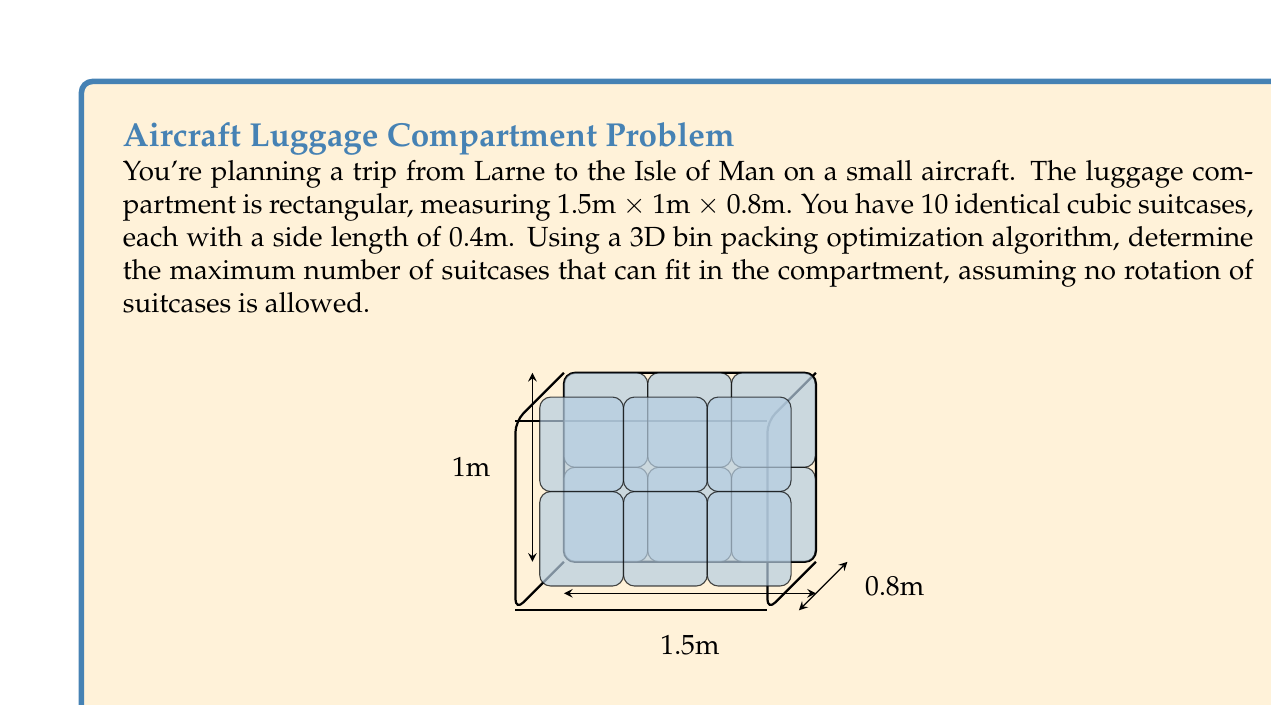Provide a solution to this math problem. Let's approach this step-by-step:

1) First, we need to determine how many suitcases can fit along each dimension of the compartment:

   Length: $\frac{1.5\text{m}}{0.4\text{m}} = 3.75$ (rounds down to 3)
   Width: $\frac{1\text{m}}{0.4\text{m}} = 2.5$ (rounds down to 2)
   Height: $\frac{0.8\text{m}}{0.4\text{m}} = 2$

2) The maximum number of suitcases that can fit is the product of these numbers:

   $$3 \times 2 \times 2 = 12$$

3) However, we're limited to 10 suitcases in total.

4) To optimize the packing, we can use a simple 3D bin packing algorithm:
   - Start from one corner of the compartment
   - Place suitcases in a 3x2x2 arrangement
   - This will use all 10 available suitcases

5) The arrangement will look like this:
   - 3 suitcases along the length
   - 2 suitcases along the width
   - 2 suitcases along the height
   - $3 \times 2 \times 2 = 12$, but we only have 10, so the last two spaces will be empty

Therefore, all 10 suitcases can fit in the compartment with this optimal arrangement.
Answer: 10 suitcases 